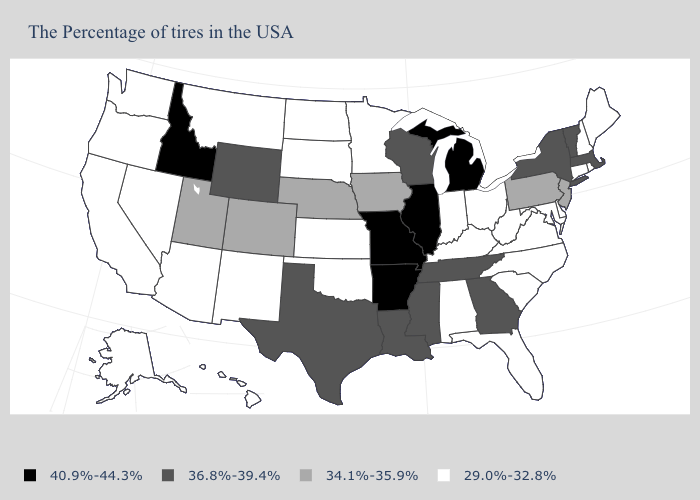What is the value of Rhode Island?
Keep it brief. 29.0%-32.8%. What is the lowest value in the South?
Answer briefly. 29.0%-32.8%. Does the first symbol in the legend represent the smallest category?
Concise answer only. No. What is the value of Alabama?
Give a very brief answer. 29.0%-32.8%. What is the value of Colorado?
Concise answer only. 34.1%-35.9%. Among the states that border Connecticut , which have the lowest value?
Give a very brief answer. Rhode Island. Does Louisiana have the lowest value in the South?
Give a very brief answer. No. What is the value of New Jersey?
Short answer required. 34.1%-35.9%. Does the first symbol in the legend represent the smallest category?
Give a very brief answer. No. Does Arkansas have the highest value in the USA?
Be succinct. Yes. What is the lowest value in the USA?
Give a very brief answer. 29.0%-32.8%. What is the value of Kentucky?
Short answer required. 29.0%-32.8%. Does the map have missing data?
Short answer required. No. What is the value of Oregon?
Write a very short answer. 29.0%-32.8%. Does Virginia have the highest value in the USA?
Keep it brief. No. 